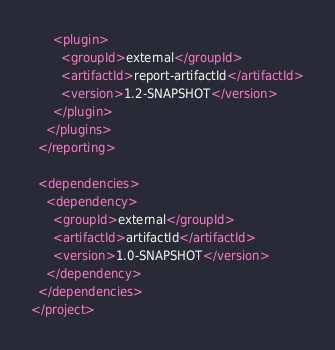<code> <loc_0><loc_0><loc_500><loc_500><_XML_>      <plugin>
        <groupId>external</groupId>
        <artifactId>report-artifactId</artifactId>
        <version>1.2-SNAPSHOT</version>
      </plugin>
    </plugins>
  </reporting>
  
  <dependencies>
    <dependency>
      <groupId>external</groupId>
      <artifactId>artifactId</artifactId>
      <version>1.0-SNAPSHOT</version>
    </dependency>
  </dependencies>
</project>
</code> 